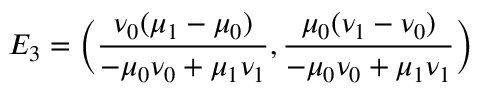<formula> <loc_0><loc_0><loc_500><loc_500>E _ { 3 } = \left ( \frac { \nu _ { 0 } ( \mu _ { 1 } - \mu _ { 0 } ) } { - \mu _ { 0 } \nu _ { 0 } + \mu _ { 1 } \nu _ { 1 } } , \frac { \mu _ { 0 } ( \nu _ { 1 } - \nu _ { 0 } ) } { - \mu _ { 0 } \nu _ { 0 } + \mu _ { 1 } \nu _ { 1 } } \right )</formula> 